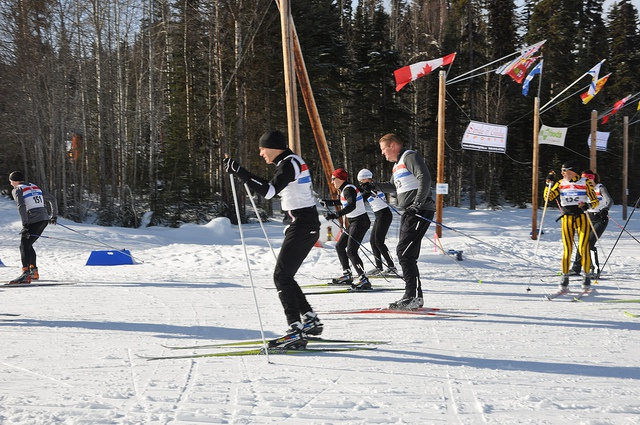Describe the objects in this image and their specific colors. I can see people in gray, black, lightgray, and darkgray tones, people in gray, black, darkgray, and lightgray tones, people in gray, black, olive, darkgray, and lightgray tones, people in gray, black, and darkgray tones, and people in gray, black, lightgray, and darkgray tones in this image. 